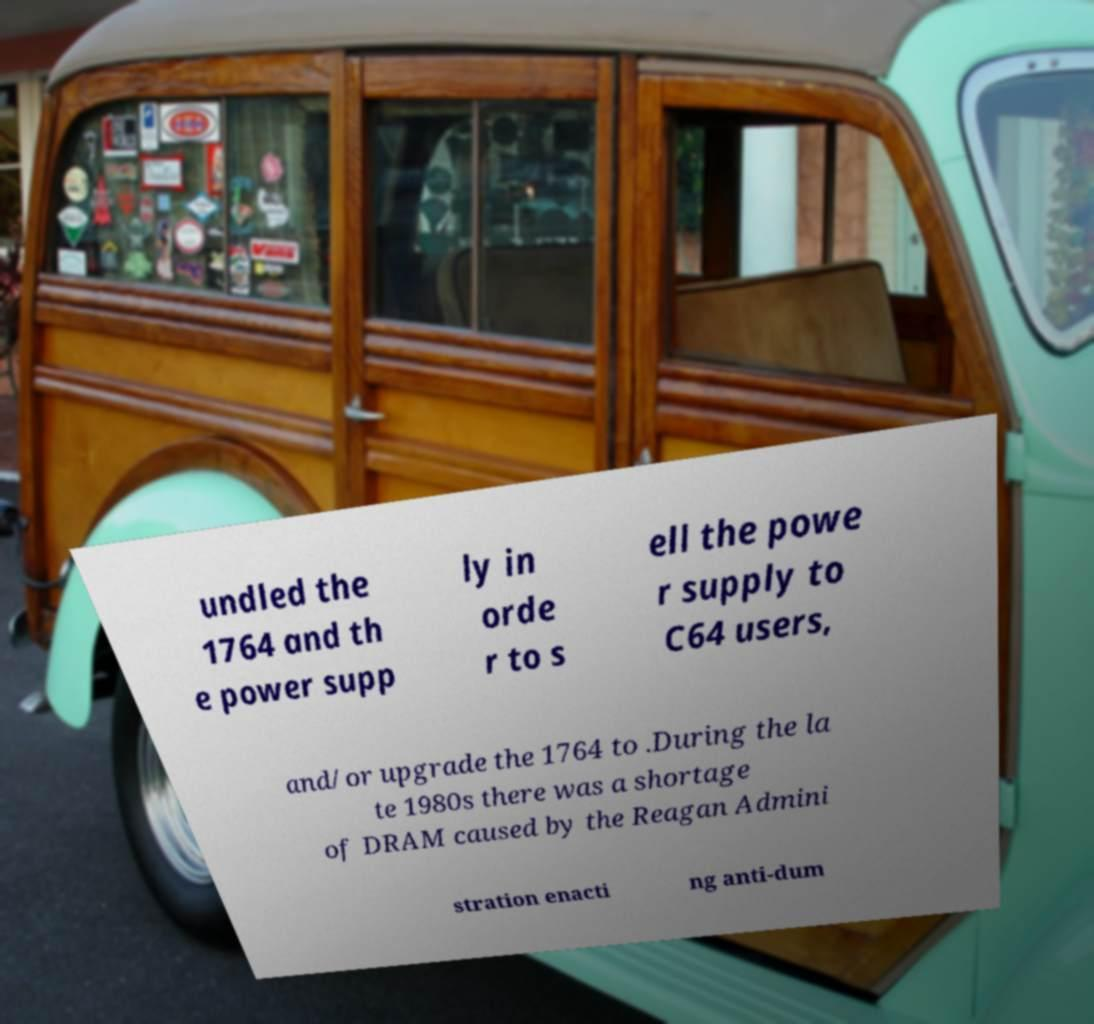For documentation purposes, I need the text within this image transcribed. Could you provide that? undled the 1764 and th e power supp ly in orde r to s ell the powe r supply to C64 users, and/or upgrade the 1764 to .During the la te 1980s there was a shortage of DRAM caused by the Reagan Admini stration enacti ng anti-dum 